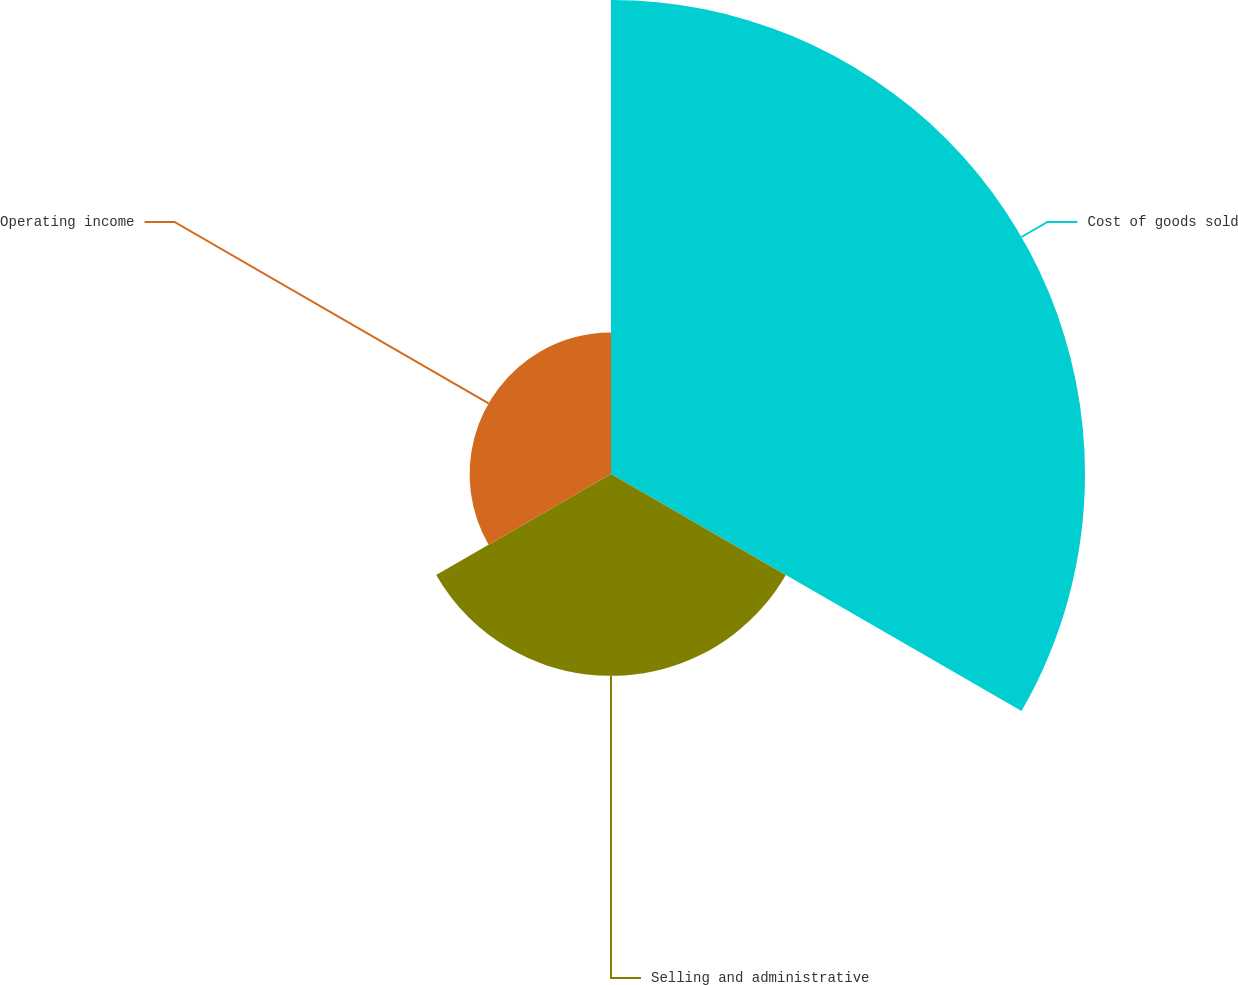<chart> <loc_0><loc_0><loc_500><loc_500><pie_chart><fcel>Cost of goods sold<fcel>Selling and administrative<fcel>Operating income<nl><fcel>58.0%<fcel>24.7%<fcel>17.3%<nl></chart> 